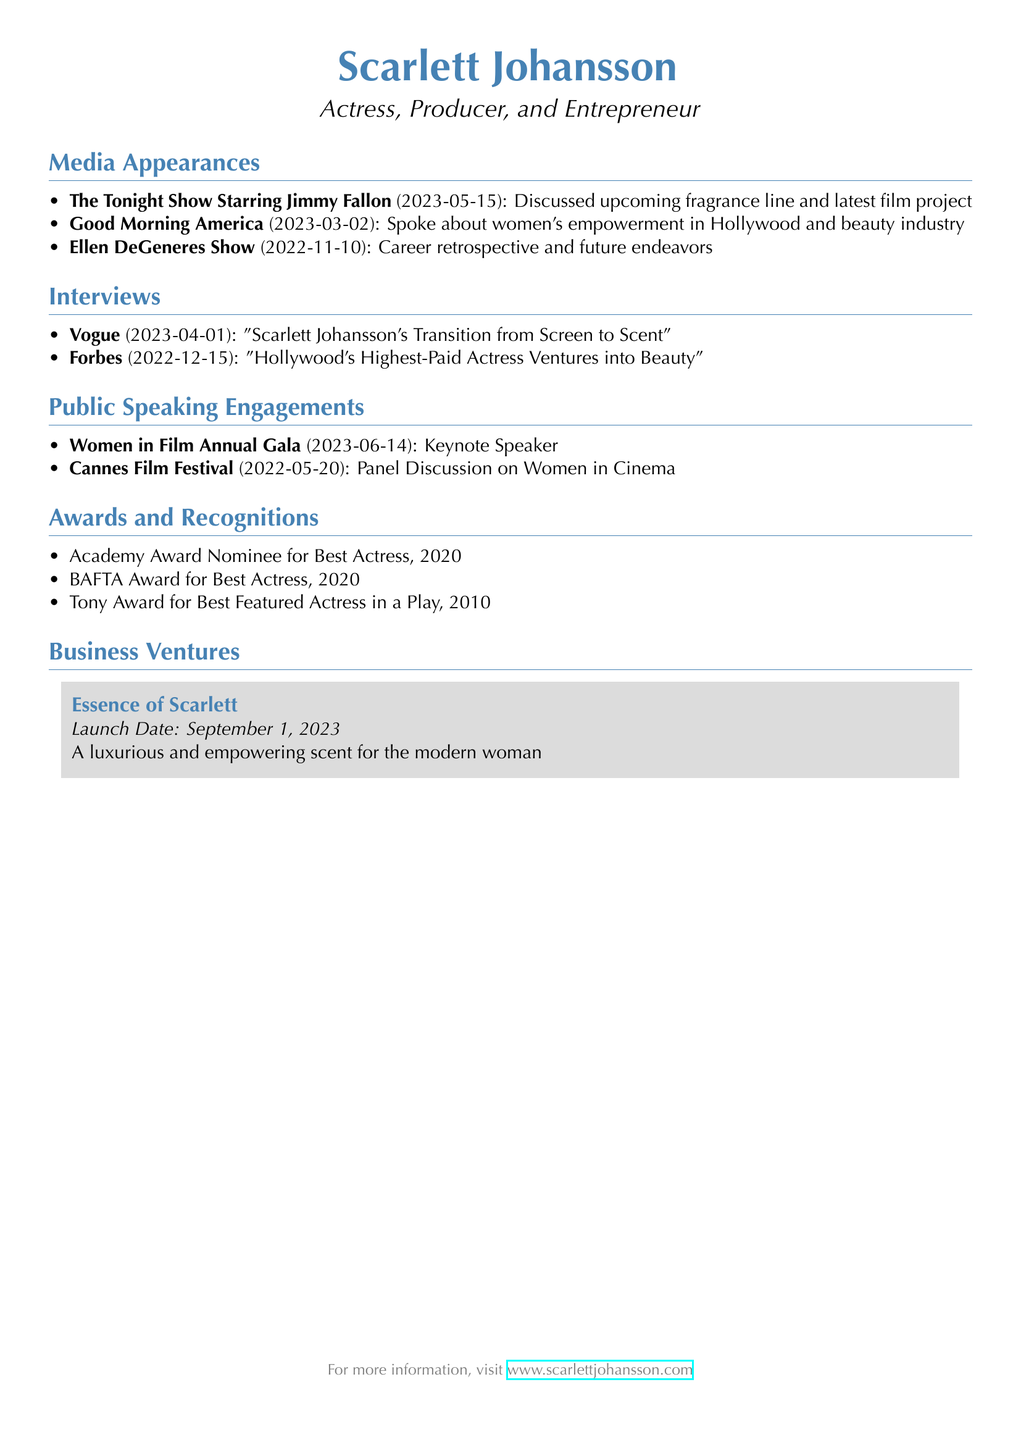What is the name of the fragrance line? The fragrance line mentioned in the document is named "Essence of Scarlett."
Answer: Essence of Scarlett When was the fragrance line launched? The document states the launch date of the fragrance line is September 1, 2023.
Answer: September 1, 2023 What was the topic discussed on "Good Morning America"? In the document, the topic discussed on "Good Morning America" is women's empowerment in Hollywood and the beauty industry.
Answer: Women's empowerment in Hollywood and beauty industry How many media appearances are listed? The document lists three media appearances made by Scarlett Johansson.
Answer: 3 Which award did Scarlett Johansson win in 2010? According to the document, she won the Tony Award for Best Featured Actress in a Play in 2010.
Answer: Tony Award for Best Featured Actress in a Play What role did Scarlett Johansson have at the Women in Film Annual Gala? In the document, it is stated that she served as the keynote speaker at the Women in Film Annual Gala.
Answer: Keynote Speaker What is the focus of the interview published in Vogue? The interview in Vogue focuses on Scarlett Johansson's transition from screen to scent.
Answer: Scarlett Johansson's Transition from Screen to Scent How many awards and recognitions are mentioned? The document mentions three awards and recognitions received by Scarlett Johansson.
Answer: 3 